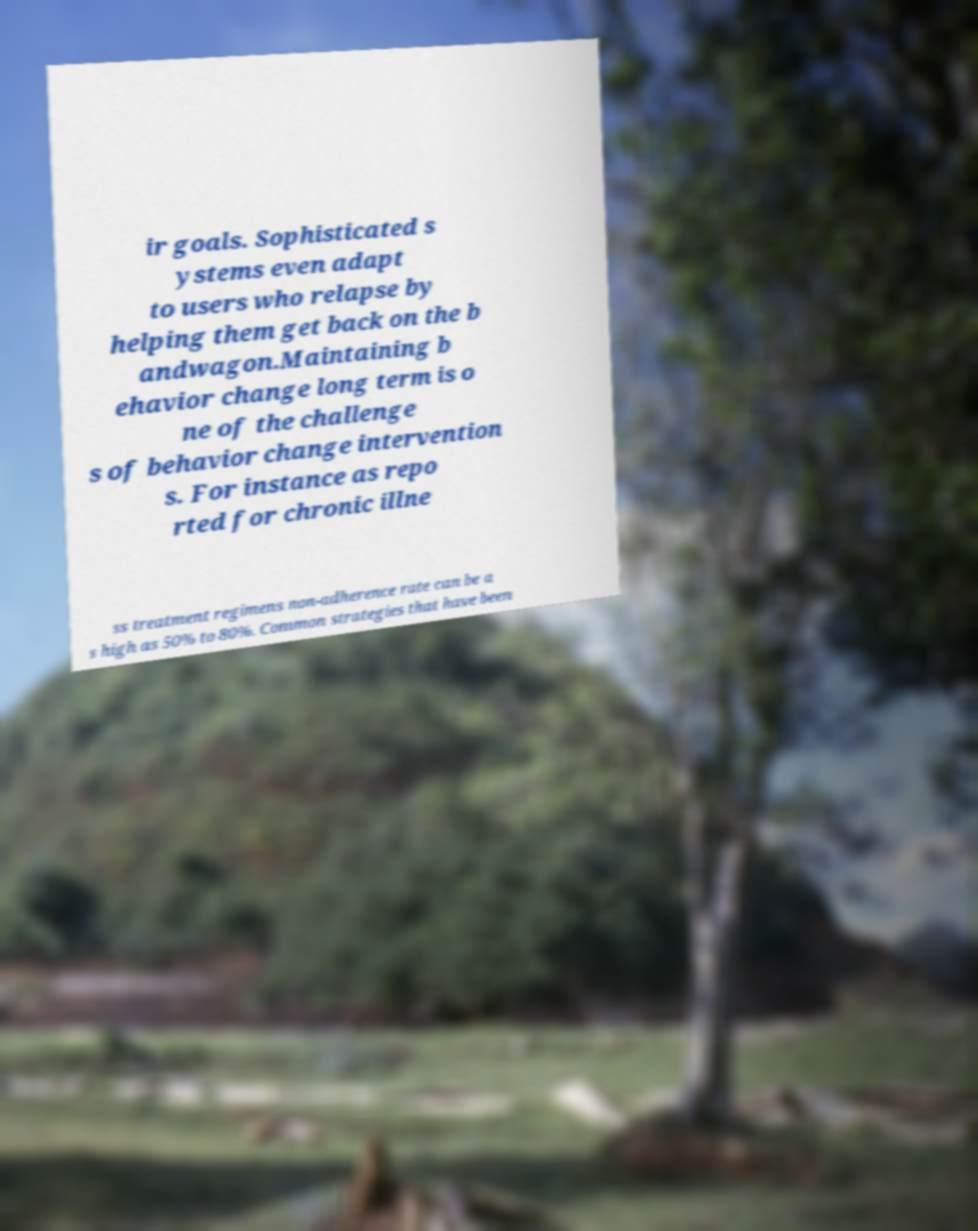Please identify and transcribe the text found in this image. ir goals. Sophisticated s ystems even adapt to users who relapse by helping them get back on the b andwagon.Maintaining b ehavior change long term is o ne of the challenge s of behavior change intervention s. For instance as repo rted for chronic illne ss treatment regimens non-adherence rate can be a s high as 50% to 80%. Common strategies that have been 